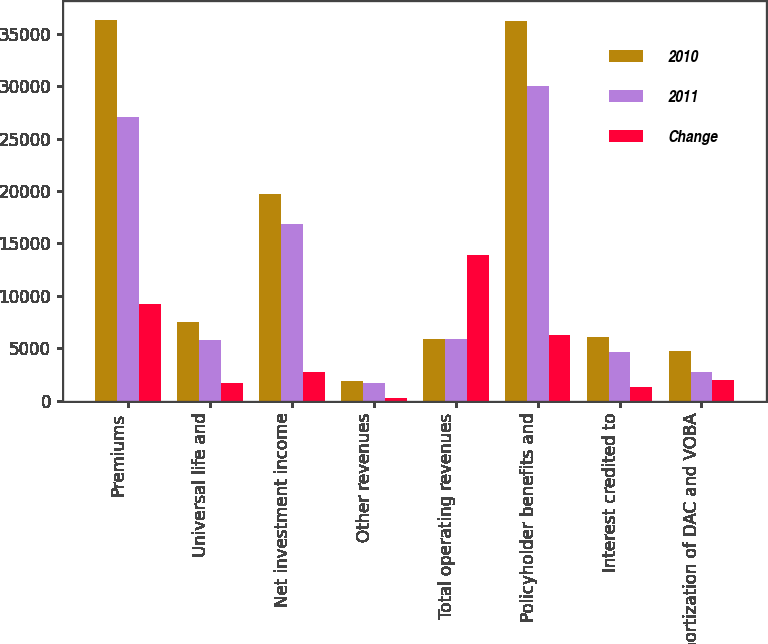<chart> <loc_0><loc_0><loc_500><loc_500><stacked_bar_chart><ecel><fcel>Premiums<fcel>Universal life and<fcel>Net investment income<fcel>Other revenues<fcel>Total operating revenues<fcel>Policyholder benefits and<fcel>Interest credited to<fcel>Amortization of DAC and VOBA<nl><fcel>2010<fcel>36269<fcel>7528<fcel>19676<fcel>1911<fcel>5937<fcel>36227<fcel>6057<fcel>4799<nl><fcel>2011<fcel>27071<fcel>5817<fcel>16880<fcel>1675<fcel>5937<fcel>29972<fcel>4697<fcel>2802<nl><fcel>Change<fcel>9198<fcel>1711<fcel>2796<fcel>236<fcel>13941<fcel>6255<fcel>1360<fcel>1997<nl></chart> 